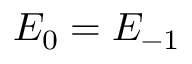<formula> <loc_0><loc_0><loc_500><loc_500>E _ { 0 } = E _ { - 1 }</formula> 